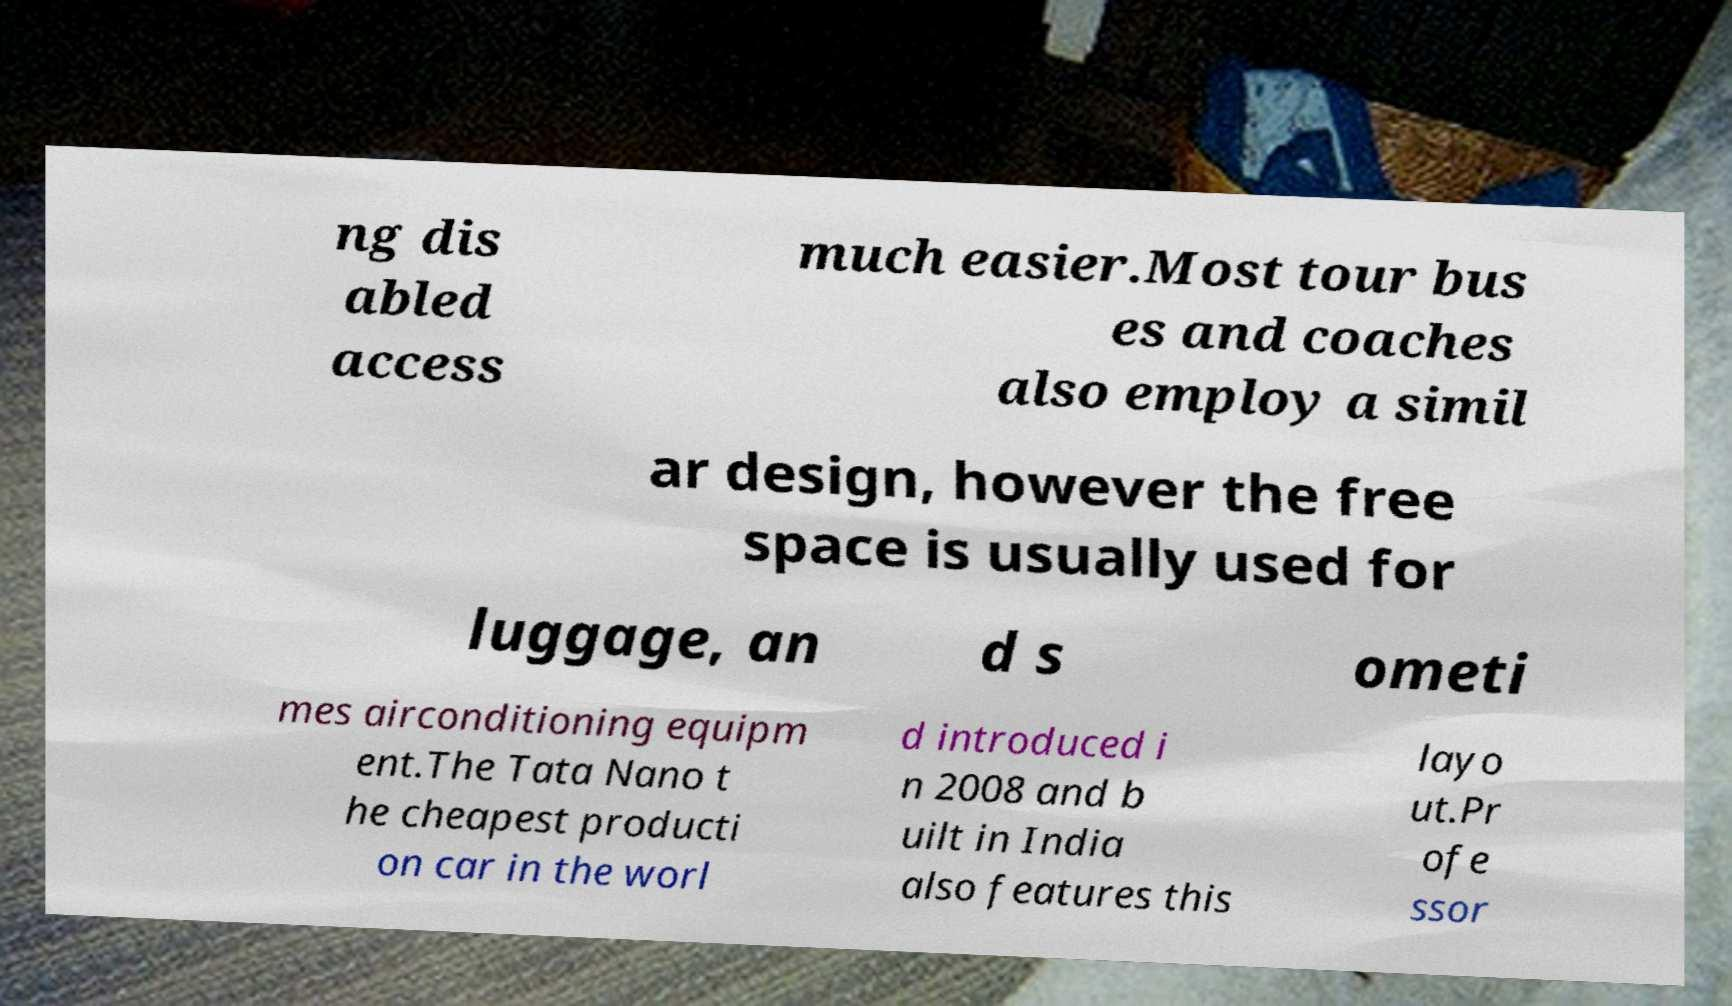Could you assist in decoding the text presented in this image and type it out clearly? ng dis abled access much easier.Most tour bus es and coaches also employ a simil ar design, however the free space is usually used for luggage, an d s ometi mes airconditioning equipm ent.The Tata Nano t he cheapest producti on car in the worl d introduced i n 2008 and b uilt in India also features this layo ut.Pr ofe ssor 